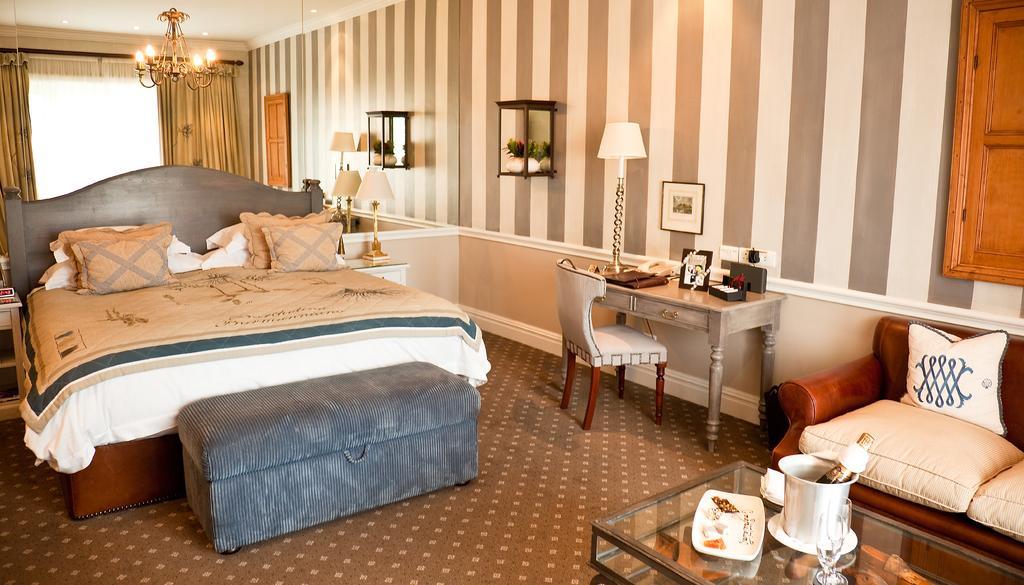Could you give a brief overview of what you see in this image? This is inside view picture of a house. At the right side of the picture we can see a sofa with white cushions on it. this is window. Here we can see a glass table on which we can see a plate and some food on it. This is a bed with blanket and pillows on it. This is a luggage bag. On the background we can see a wall with curtains. This is a ceiling and it's a ceiling light. This is a floor carpet. Here we can see a table and photo frame and a lamp on it. This is a chair. this is a socket. 